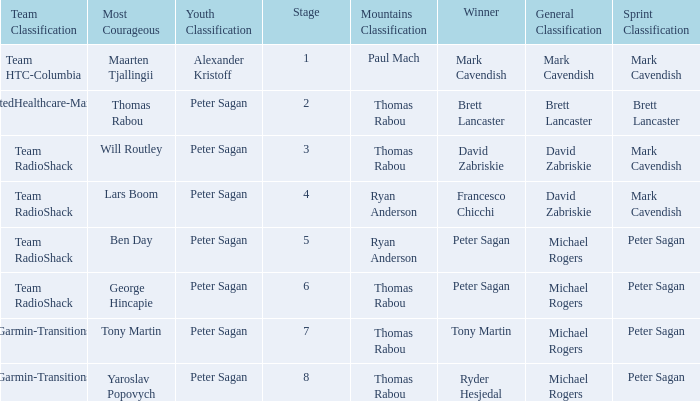When Yaroslav Popovych won most corageous, who won the mountains classification? Thomas Rabou. 